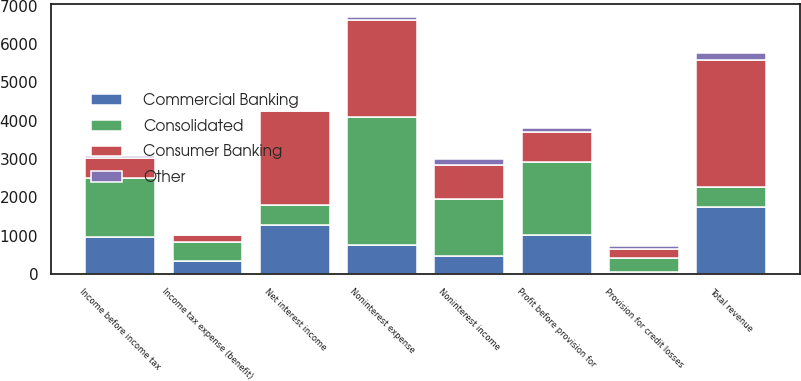<chart> <loc_0><loc_0><loc_500><loc_500><stacked_bar_chart><ecel><fcel>Net interest income<fcel>Noninterest income<fcel>Total revenue<fcel>Noninterest expense<fcel>Profit before provision for<fcel>Provision for credit losses<fcel>Income before income tax<fcel>Income tax expense (benefit)<nl><fcel>Consumer Banking<fcel>2443<fcel>883<fcel>3326<fcel>2547<fcel>779<fcel>243<fcel>536<fcel>191<nl><fcel>Commercial Banking<fcel>1288<fcel>466<fcel>1754<fcel>741<fcel>1013<fcel>47<fcel>966<fcel>335<nl><fcel>Other<fcel>27<fcel>148<fcel>175<fcel>64<fcel>111<fcel>79<fcel>32<fcel>37<nl><fcel>Consolidated<fcel>512.5<fcel>1497<fcel>512.5<fcel>3352<fcel>1903<fcel>369<fcel>1534<fcel>489<nl></chart> 